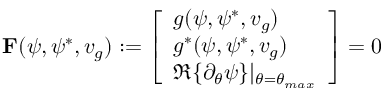Convert formula to latex. <formula><loc_0><loc_0><loc_500><loc_500>F ( \psi , \psi ^ { * } , v _ { g } ) \colon = \left [ \begin{array} { l } { g ( \psi , \psi ^ { * } , v _ { g } ) } \\ { g ^ { * } ( \psi , \psi ^ { * } , v _ { g } ) } \\ { \Re \{ \partial _ { \theta } \psi \} | _ { \theta = \theta _ { \max } } } \end{array} \right ] = 0</formula> 